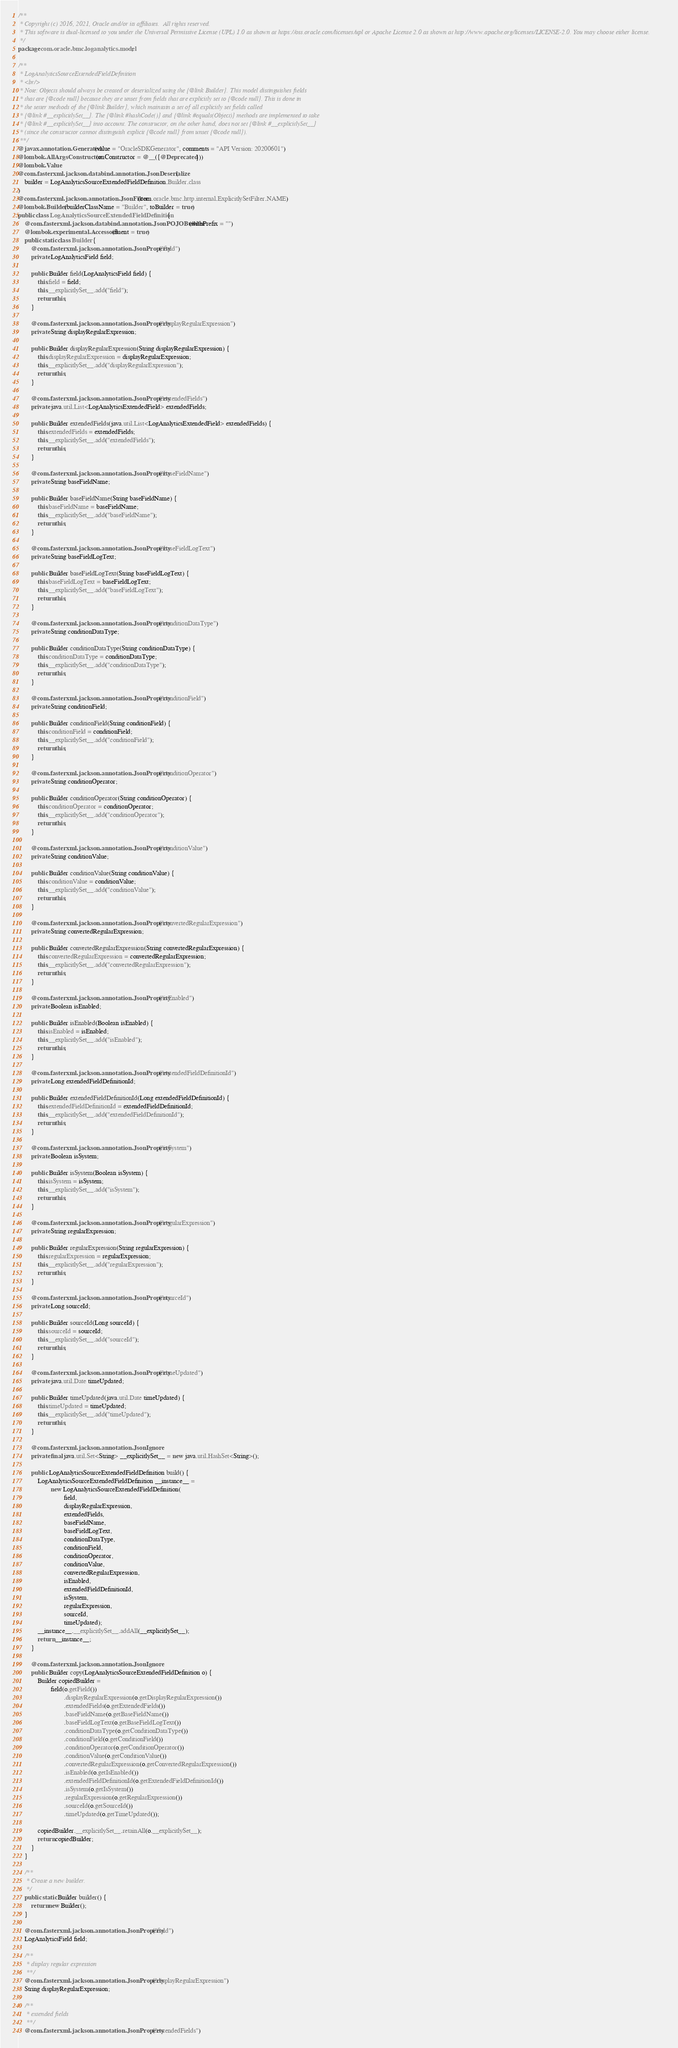<code> <loc_0><loc_0><loc_500><loc_500><_Java_>/**
 * Copyright (c) 2016, 2021, Oracle and/or its affiliates.  All rights reserved.
 * This software is dual-licensed to you under the Universal Permissive License (UPL) 1.0 as shown at https://oss.oracle.com/licenses/upl or Apache License 2.0 as shown at http://www.apache.org/licenses/LICENSE-2.0. You may choose either license.
 */
package com.oracle.bmc.loganalytics.model;

/**
 * LogAnalyticsSourceExtendedFieldDefinition
 * <br/>
 * Note: Objects should always be created or deserialized using the {@link Builder}. This model distinguishes fields
 * that are {@code null} because they are unset from fields that are explicitly set to {@code null}. This is done in
 * the setter methods of the {@link Builder}, which maintain a set of all explicitly set fields called
 * {@link #__explicitlySet__}. The {@link #hashCode()} and {@link #equals(Object)} methods are implemented to take
 * {@link #__explicitlySet__} into account. The constructor, on the other hand, does not set {@link #__explicitlySet__}
 * (since the constructor cannot distinguish explicit {@code null} from unset {@code null}).
 **/
@javax.annotation.Generated(value = "OracleSDKGenerator", comments = "API Version: 20200601")
@lombok.AllArgsConstructor(onConstructor = @__({@Deprecated}))
@lombok.Value
@com.fasterxml.jackson.databind.annotation.JsonDeserialize(
    builder = LogAnalyticsSourceExtendedFieldDefinition.Builder.class
)
@com.fasterxml.jackson.annotation.JsonFilter(com.oracle.bmc.http.internal.ExplicitlySetFilter.NAME)
@lombok.Builder(builderClassName = "Builder", toBuilder = true)
public class LogAnalyticsSourceExtendedFieldDefinition {
    @com.fasterxml.jackson.databind.annotation.JsonPOJOBuilder(withPrefix = "")
    @lombok.experimental.Accessors(fluent = true)
    public static class Builder {
        @com.fasterxml.jackson.annotation.JsonProperty("field")
        private LogAnalyticsField field;

        public Builder field(LogAnalyticsField field) {
            this.field = field;
            this.__explicitlySet__.add("field");
            return this;
        }

        @com.fasterxml.jackson.annotation.JsonProperty("displayRegularExpression")
        private String displayRegularExpression;

        public Builder displayRegularExpression(String displayRegularExpression) {
            this.displayRegularExpression = displayRegularExpression;
            this.__explicitlySet__.add("displayRegularExpression");
            return this;
        }

        @com.fasterxml.jackson.annotation.JsonProperty("extendedFields")
        private java.util.List<LogAnalyticsExtendedField> extendedFields;

        public Builder extendedFields(java.util.List<LogAnalyticsExtendedField> extendedFields) {
            this.extendedFields = extendedFields;
            this.__explicitlySet__.add("extendedFields");
            return this;
        }

        @com.fasterxml.jackson.annotation.JsonProperty("baseFieldName")
        private String baseFieldName;

        public Builder baseFieldName(String baseFieldName) {
            this.baseFieldName = baseFieldName;
            this.__explicitlySet__.add("baseFieldName");
            return this;
        }

        @com.fasterxml.jackson.annotation.JsonProperty("baseFieldLogText")
        private String baseFieldLogText;

        public Builder baseFieldLogText(String baseFieldLogText) {
            this.baseFieldLogText = baseFieldLogText;
            this.__explicitlySet__.add("baseFieldLogText");
            return this;
        }

        @com.fasterxml.jackson.annotation.JsonProperty("conditionDataType")
        private String conditionDataType;

        public Builder conditionDataType(String conditionDataType) {
            this.conditionDataType = conditionDataType;
            this.__explicitlySet__.add("conditionDataType");
            return this;
        }

        @com.fasterxml.jackson.annotation.JsonProperty("conditionField")
        private String conditionField;

        public Builder conditionField(String conditionField) {
            this.conditionField = conditionField;
            this.__explicitlySet__.add("conditionField");
            return this;
        }

        @com.fasterxml.jackson.annotation.JsonProperty("conditionOperator")
        private String conditionOperator;

        public Builder conditionOperator(String conditionOperator) {
            this.conditionOperator = conditionOperator;
            this.__explicitlySet__.add("conditionOperator");
            return this;
        }

        @com.fasterxml.jackson.annotation.JsonProperty("conditionValue")
        private String conditionValue;

        public Builder conditionValue(String conditionValue) {
            this.conditionValue = conditionValue;
            this.__explicitlySet__.add("conditionValue");
            return this;
        }

        @com.fasterxml.jackson.annotation.JsonProperty("convertedRegularExpression")
        private String convertedRegularExpression;

        public Builder convertedRegularExpression(String convertedRegularExpression) {
            this.convertedRegularExpression = convertedRegularExpression;
            this.__explicitlySet__.add("convertedRegularExpression");
            return this;
        }

        @com.fasterxml.jackson.annotation.JsonProperty("isEnabled")
        private Boolean isEnabled;

        public Builder isEnabled(Boolean isEnabled) {
            this.isEnabled = isEnabled;
            this.__explicitlySet__.add("isEnabled");
            return this;
        }

        @com.fasterxml.jackson.annotation.JsonProperty("extendedFieldDefinitionId")
        private Long extendedFieldDefinitionId;

        public Builder extendedFieldDefinitionId(Long extendedFieldDefinitionId) {
            this.extendedFieldDefinitionId = extendedFieldDefinitionId;
            this.__explicitlySet__.add("extendedFieldDefinitionId");
            return this;
        }

        @com.fasterxml.jackson.annotation.JsonProperty("isSystem")
        private Boolean isSystem;

        public Builder isSystem(Boolean isSystem) {
            this.isSystem = isSystem;
            this.__explicitlySet__.add("isSystem");
            return this;
        }

        @com.fasterxml.jackson.annotation.JsonProperty("regularExpression")
        private String regularExpression;

        public Builder regularExpression(String regularExpression) {
            this.regularExpression = regularExpression;
            this.__explicitlySet__.add("regularExpression");
            return this;
        }

        @com.fasterxml.jackson.annotation.JsonProperty("sourceId")
        private Long sourceId;

        public Builder sourceId(Long sourceId) {
            this.sourceId = sourceId;
            this.__explicitlySet__.add("sourceId");
            return this;
        }

        @com.fasterxml.jackson.annotation.JsonProperty("timeUpdated")
        private java.util.Date timeUpdated;

        public Builder timeUpdated(java.util.Date timeUpdated) {
            this.timeUpdated = timeUpdated;
            this.__explicitlySet__.add("timeUpdated");
            return this;
        }

        @com.fasterxml.jackson.annotation.JsonIgnore
        private final java.util.Set<String> __explicitlySet__ = new java.util.HashSet<String>();

        public LogAnalyticsSourceExtendedFieldDefinition build() {
            LogAnalyticsSourceExtendedFieldDefinition __instance__ =
                    new LogAnalyticsSourceExtendedFieldDefinition(
                            field,
                            displayRegularExpression,
                            extendedFields,
                            baseFieldName,
                            baseFieldLogText,
                            conditionDataType,
                            conditionField,
                            conditionOperator,
                            conditionValue,
                            convertedRegularExpression,
                            isEnabled,
                            extendedFieldDefinitionId,
                            isSystem,
                            regularExpression,
                            sourceId,
                            timeUpdated);
            __instance__.__explicitlySet__.addAll(__explicitlySet__);
            return __instance__;
        }

        @com.fasterxml.jackson.annotation.JsonIgnore
        public Builder copy(LogAnalyticsSourceExtendedFieldDefinition o) {
            Builder copiedBuilder =
                    field(o.getField())
                            .displayRegularExpression(o.getDisplayRegularExpression())
                            .extendedFields(o.getExtendedFields())
                            .baseFieldName(o.getBaseFieldName())
                            .baseFieldLogText(o.getBaseFieldLogText())
                            .conditionDataType(o.getConditionDataType())
                            .conditionField(o.getConditionField())
                            .conditionOperator(o.getConditionOperator())
                            .conditionValue(o.getConditionValue())
                            .convertedRegularExpression(o.getConvertedRegularExpression())
                            .isEnabled(o.getIsEnabled())
                            .extendedFieldDefinitionId(o.getExtendedFieldDefinitionId())
                            .isSystem(o.getIsSystem())
                            .regularExpression(o.getRegularExpression())
                            .sourceId(o.getSourceId())
                            .timeUpdated(o.getTimeUpdated());

            copiedBuilder.__explicitlySet__.retainAll(o.__explicitlySet__);
            return copiedBuilder;
        }
    }

    /**
     * Create a new builder.
     */
    public static Builder builder() {
        return new Builder();
    }

    @com.fasterxml.jackson.annotation.JsonProperty("field")
    LogAnalyticsField field;

    /**
     * display regular expression
     **/
    @com.fasterxml.jackson.annotation.JsonProperty("displayRegularExpression")
    String displayRegularExpression;

    /**
     * extended fields
     **/
    @com.fasterxml.jackson.annotation.JsonProperty("extendedFields")</code> 